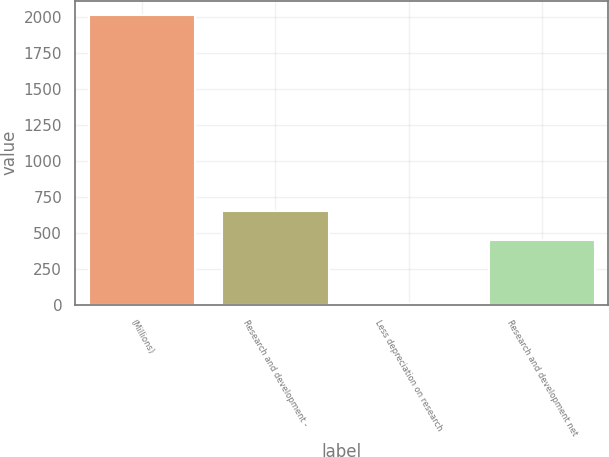Convert chart. <chart><loc_0><loc_0><loc_500><loc_500><bar_chart><fcel>(Millions)<fcel>Research and development -<fcel>Less depreciation on research<fcel>Research and development net<nl><fcel>2012<fcel>652.7<fcel>15<fcel>453<nl></chart> 